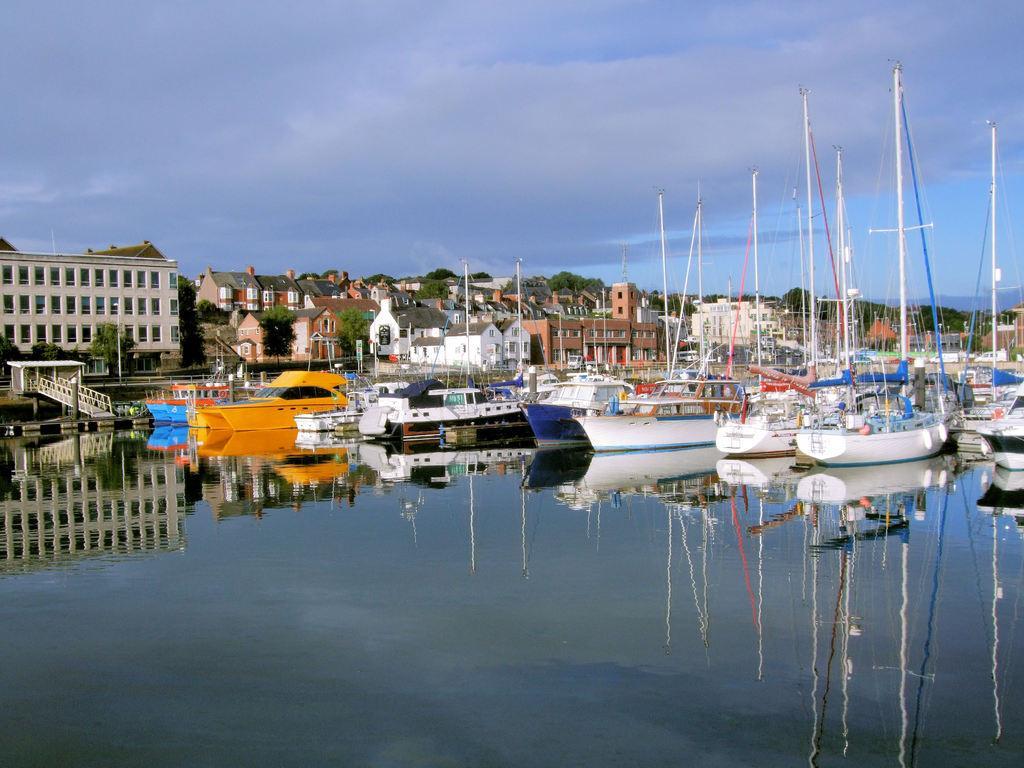Can you describe this image briefly? In this image I can see the boats on the water and these boots are colorful. To the left I can see the railing. In the background I can see many buildings, trees, clouds and the sky. 